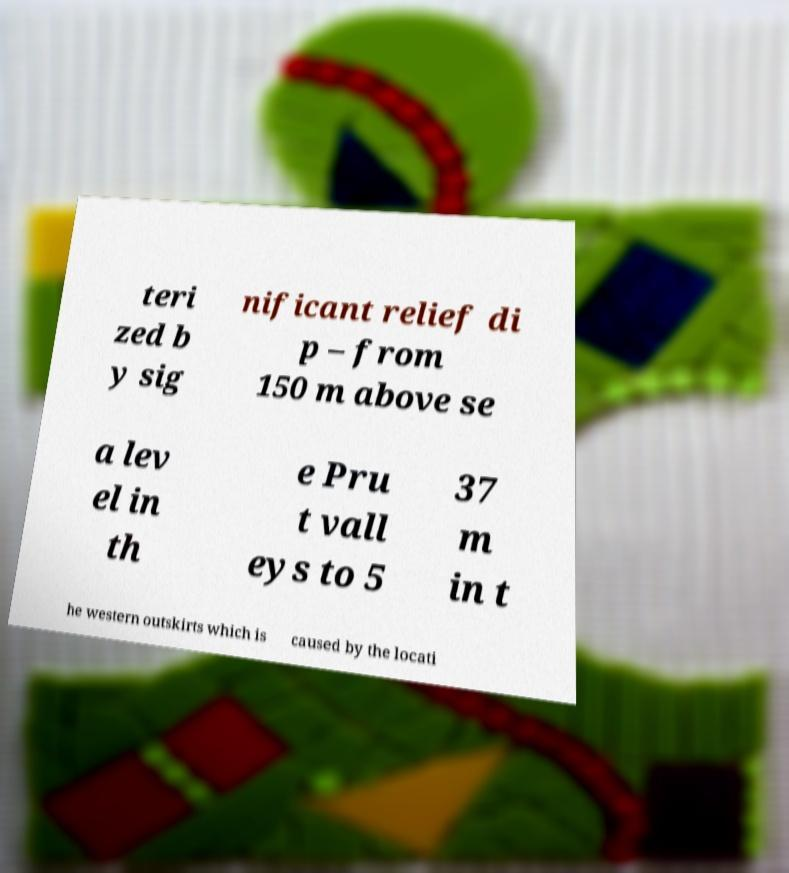For documentation purposes, I need the text within this image transcribed. Could you provide that? teri zed b y sig nificant relief di p – from 150 m above se a lev el in th e Pru t vall eys to 5 37 m in t he western outskirts which is caused by the locati 